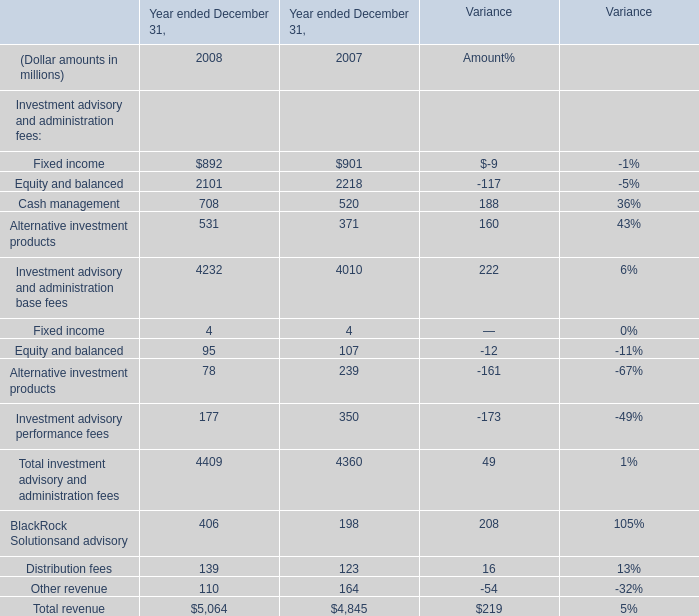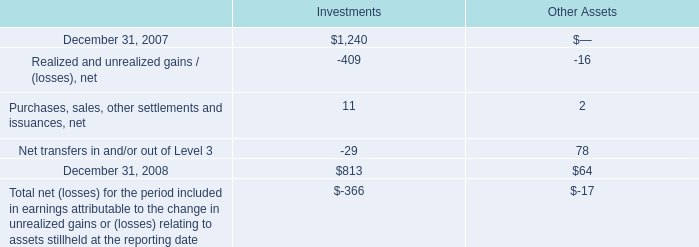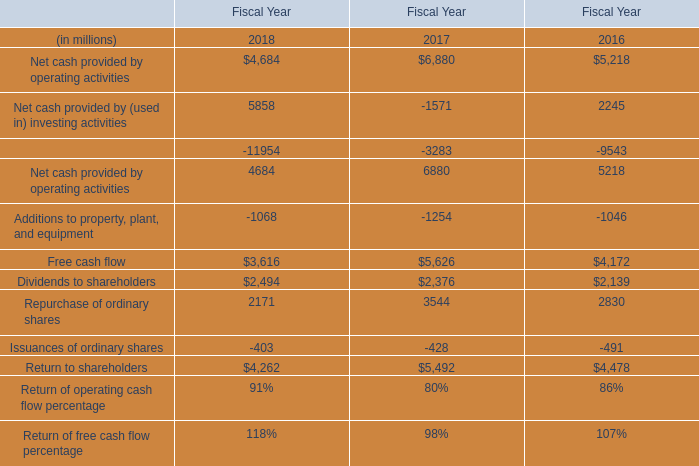What is the average amount of Net cash provided by operating activities of Fiscal Year 2016, and Equity and balanced of Year ended December 31, 2008 ? 
Computations: ((5218.0 + 2101.0) / 2)
Answer: 3659.5. 